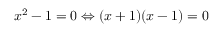Convert formula to latex. <formula><loc_0><loc_0><loc_500><loc_500>x ^ { 2 } - 1 = 0 \Leftrightarrow ( x + 1 ) ( x - 1 ) = 0</formula> 